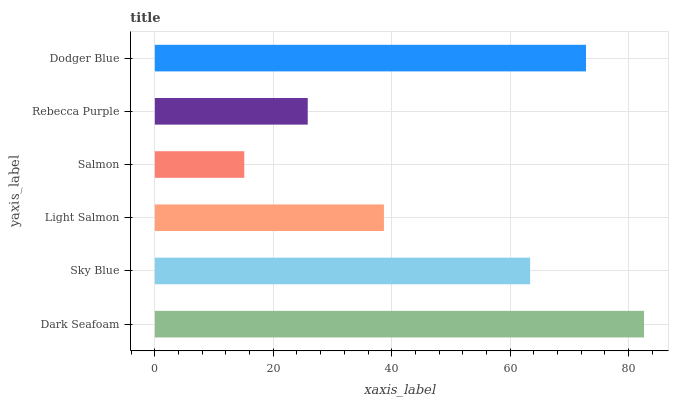Is Salmon the minimum?
Answer yes or no. Yes. Is Dark Seafoam the maximum?
Answer yes or no. Yes. Is Sky Blue the minimum?
Answer yes or no. No. Is Sky Blue the maximum?
Answer yes or no. No. Is Dark Seafoam greater than Sky Blue?
Answer yes or no. Yes. Is Sky Blue less than Dark Seafoam?
Answer yes or no. Yes. Is Sky Blue greater than Dark Seafoam?
Answer yes or no. No. Is Dark Seafoam less than Sky Blue?
Answer yes or no. No. Is Sky Blue the high median?
Answer yes or no. Yes. Is Light Salmon the low median?
Answer yes or no. Yes. Is Dark Seafoam the high median?
Answer yes or no. No. Is Salmon the low median?
Answer yes or no. No. 